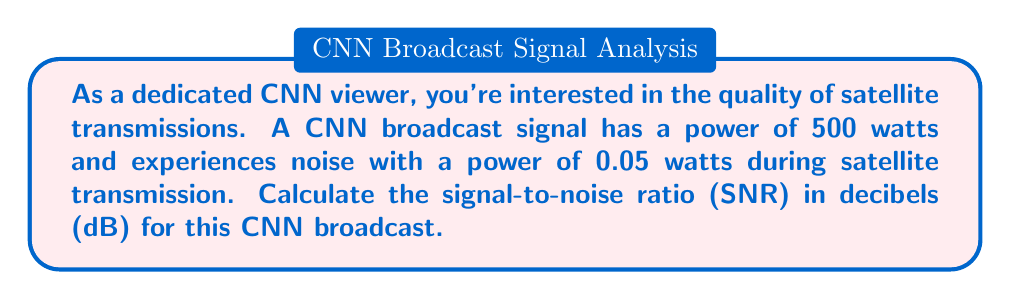Could you help me with this problem? To solve this problem, we'll follow these steps:

1) The signal-to-noise ratio (SNR) is defined as the ratio of signal power to noise power. In its simplest form:

   $$ SNR = \frac{P_{signal}}{P_{noise}} $$

   Where $P_{signal}$ is the signal power and $P_{noise}$ is the noise power.

2) We're given:
   $P_{signal} = 500$ watts
   $P_{noise} = 0.05$ watts

3) Let's calculate the ratio:

   $$ SNR = \frac{500}{0.05} = 10,000 $$

4) However, SNR is typically expressed in decibels (dB). To convert to dB, we use the formula:

   $$ SNR_{dB} = 10 \log_{10}(SNR) $$

5) Substituting our value:

   $$ SNR_{dB} = 10 \log_{10}(10,000) $$

6) Simplify:
   $$ SNR_{dB} = 10 * 4 = 40 $$

   Because $\log_{10}(10,000) = 4$

Therefore, the signal-to-noise ratio for this CNN broadcast transmission is 40 dB.
Answer: 40 dB 